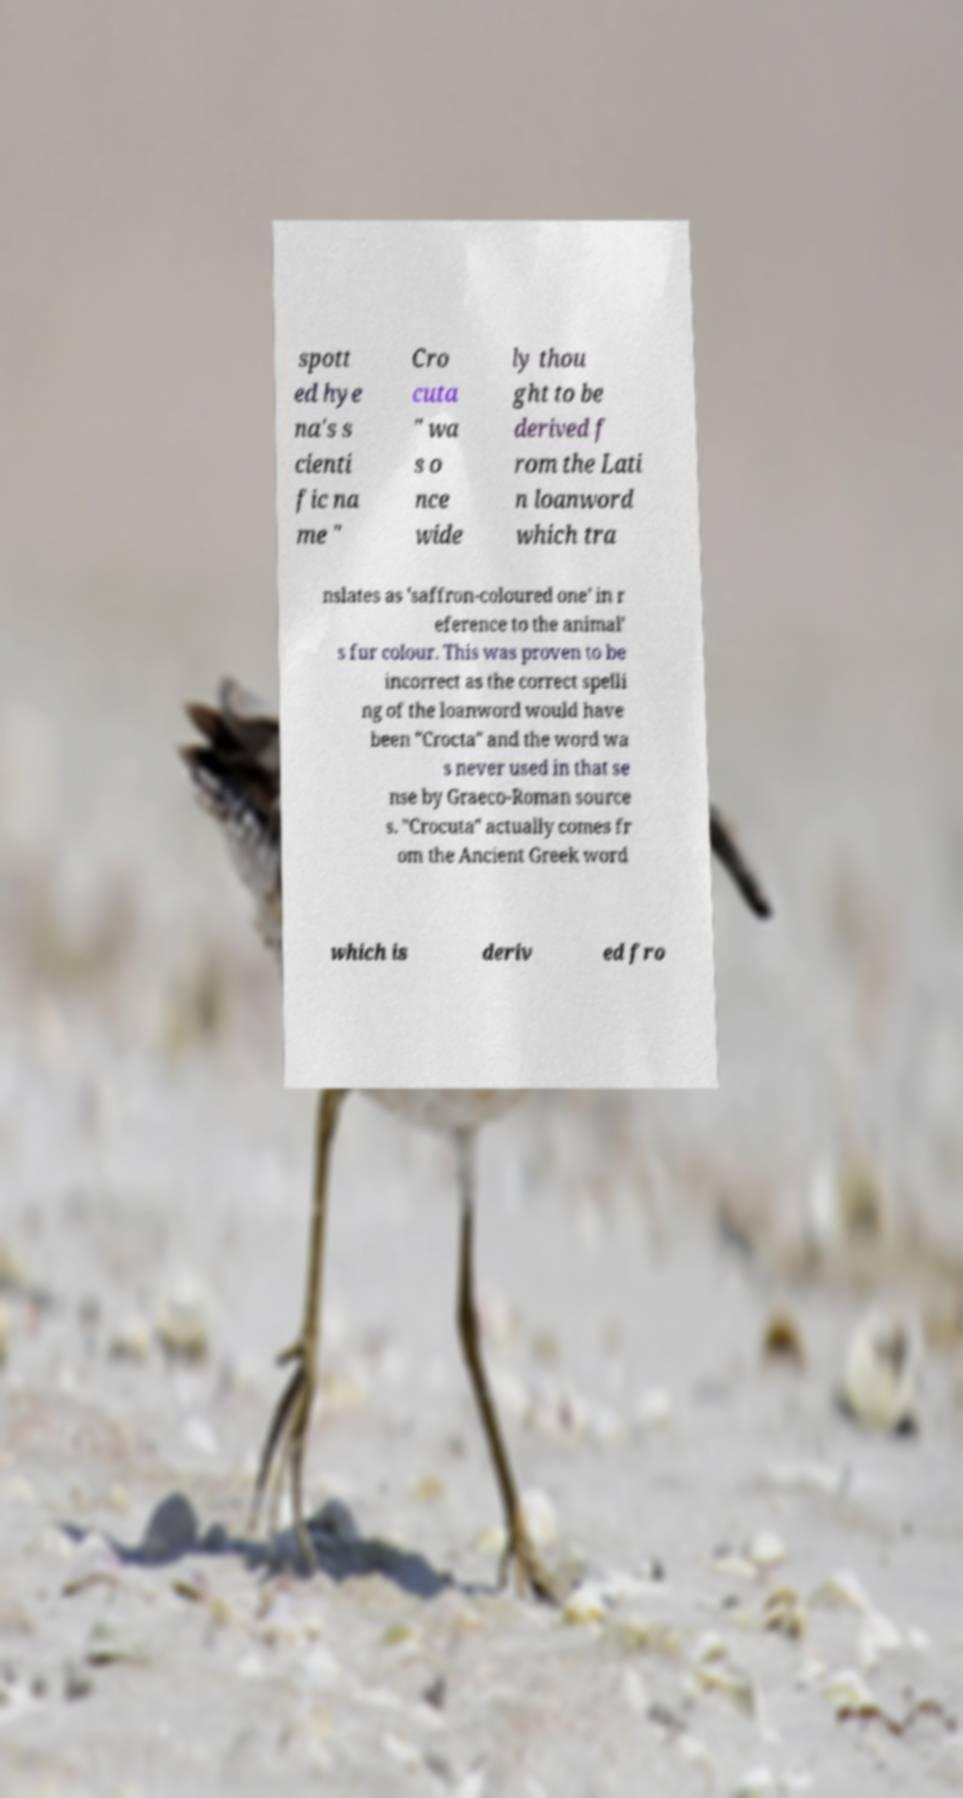Please read and relay the text visible in this image. What does it say? spott ed hye na's s cienti fic na me " Cro cuta " wa s o nce wide ly thou ght to be derived f rom the Lati n loanword which tra nslates as 'saffron-coloured one' in r eference to the animal' s fur colour. This was proven to be incorrect as the correct spelli ng of the loanword would have been "Crocta" and the word wa s never used in that se nse by Graeco-Roman source s. "Crocuta" actually comes fr om the Ancient Greek word which is deriv ed fro 